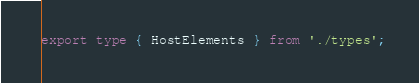<code> <loc_0><loc_0><loc_500><loc_500><_TypeScript_>
export type { HostElements } from './types';
</code> 